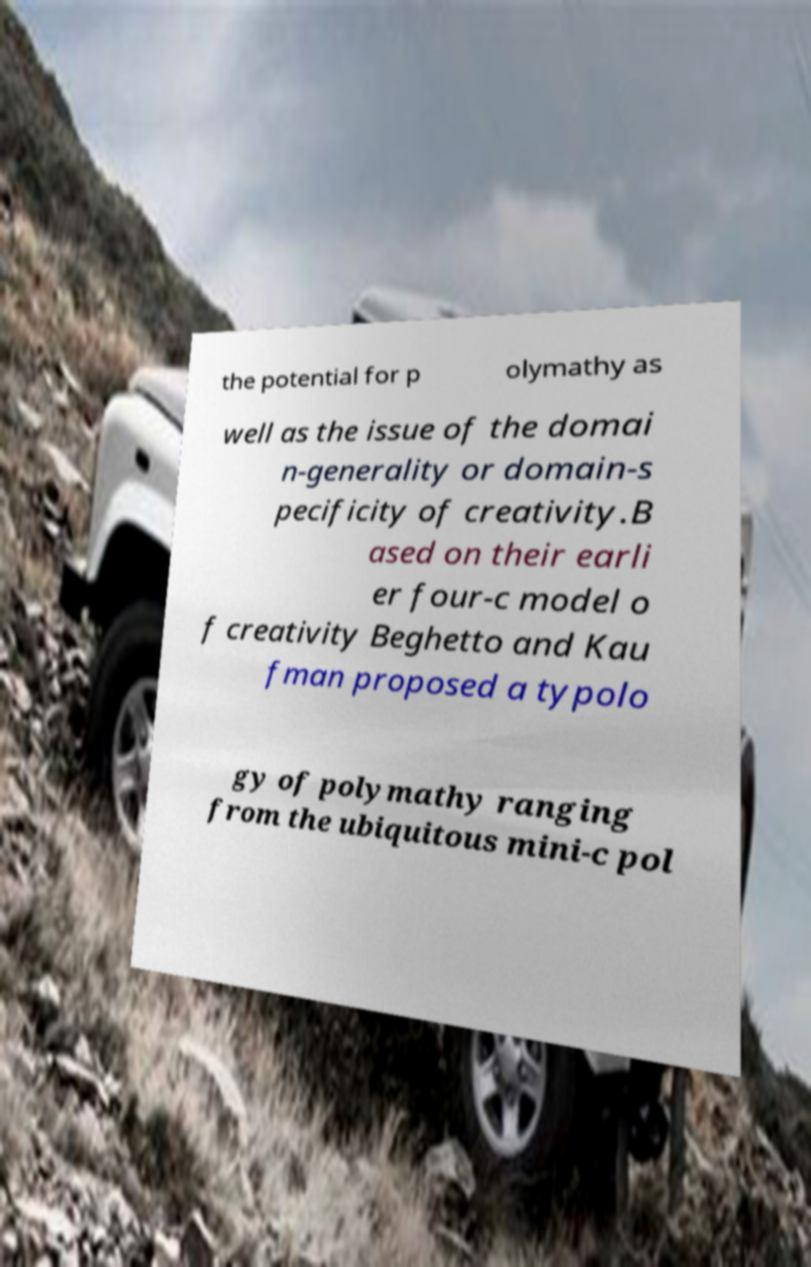Can you accurately transcribe the text from the provided image for me? the potential for p olymathy as well as the issue of the domai n-generality or domain-s pecificity of creativity.B ased on their earli er four-c model o f creativity Beghetto and Kau fman proposed a typolo gy of polymathy ranging from the ubiquitous mini-c pol 